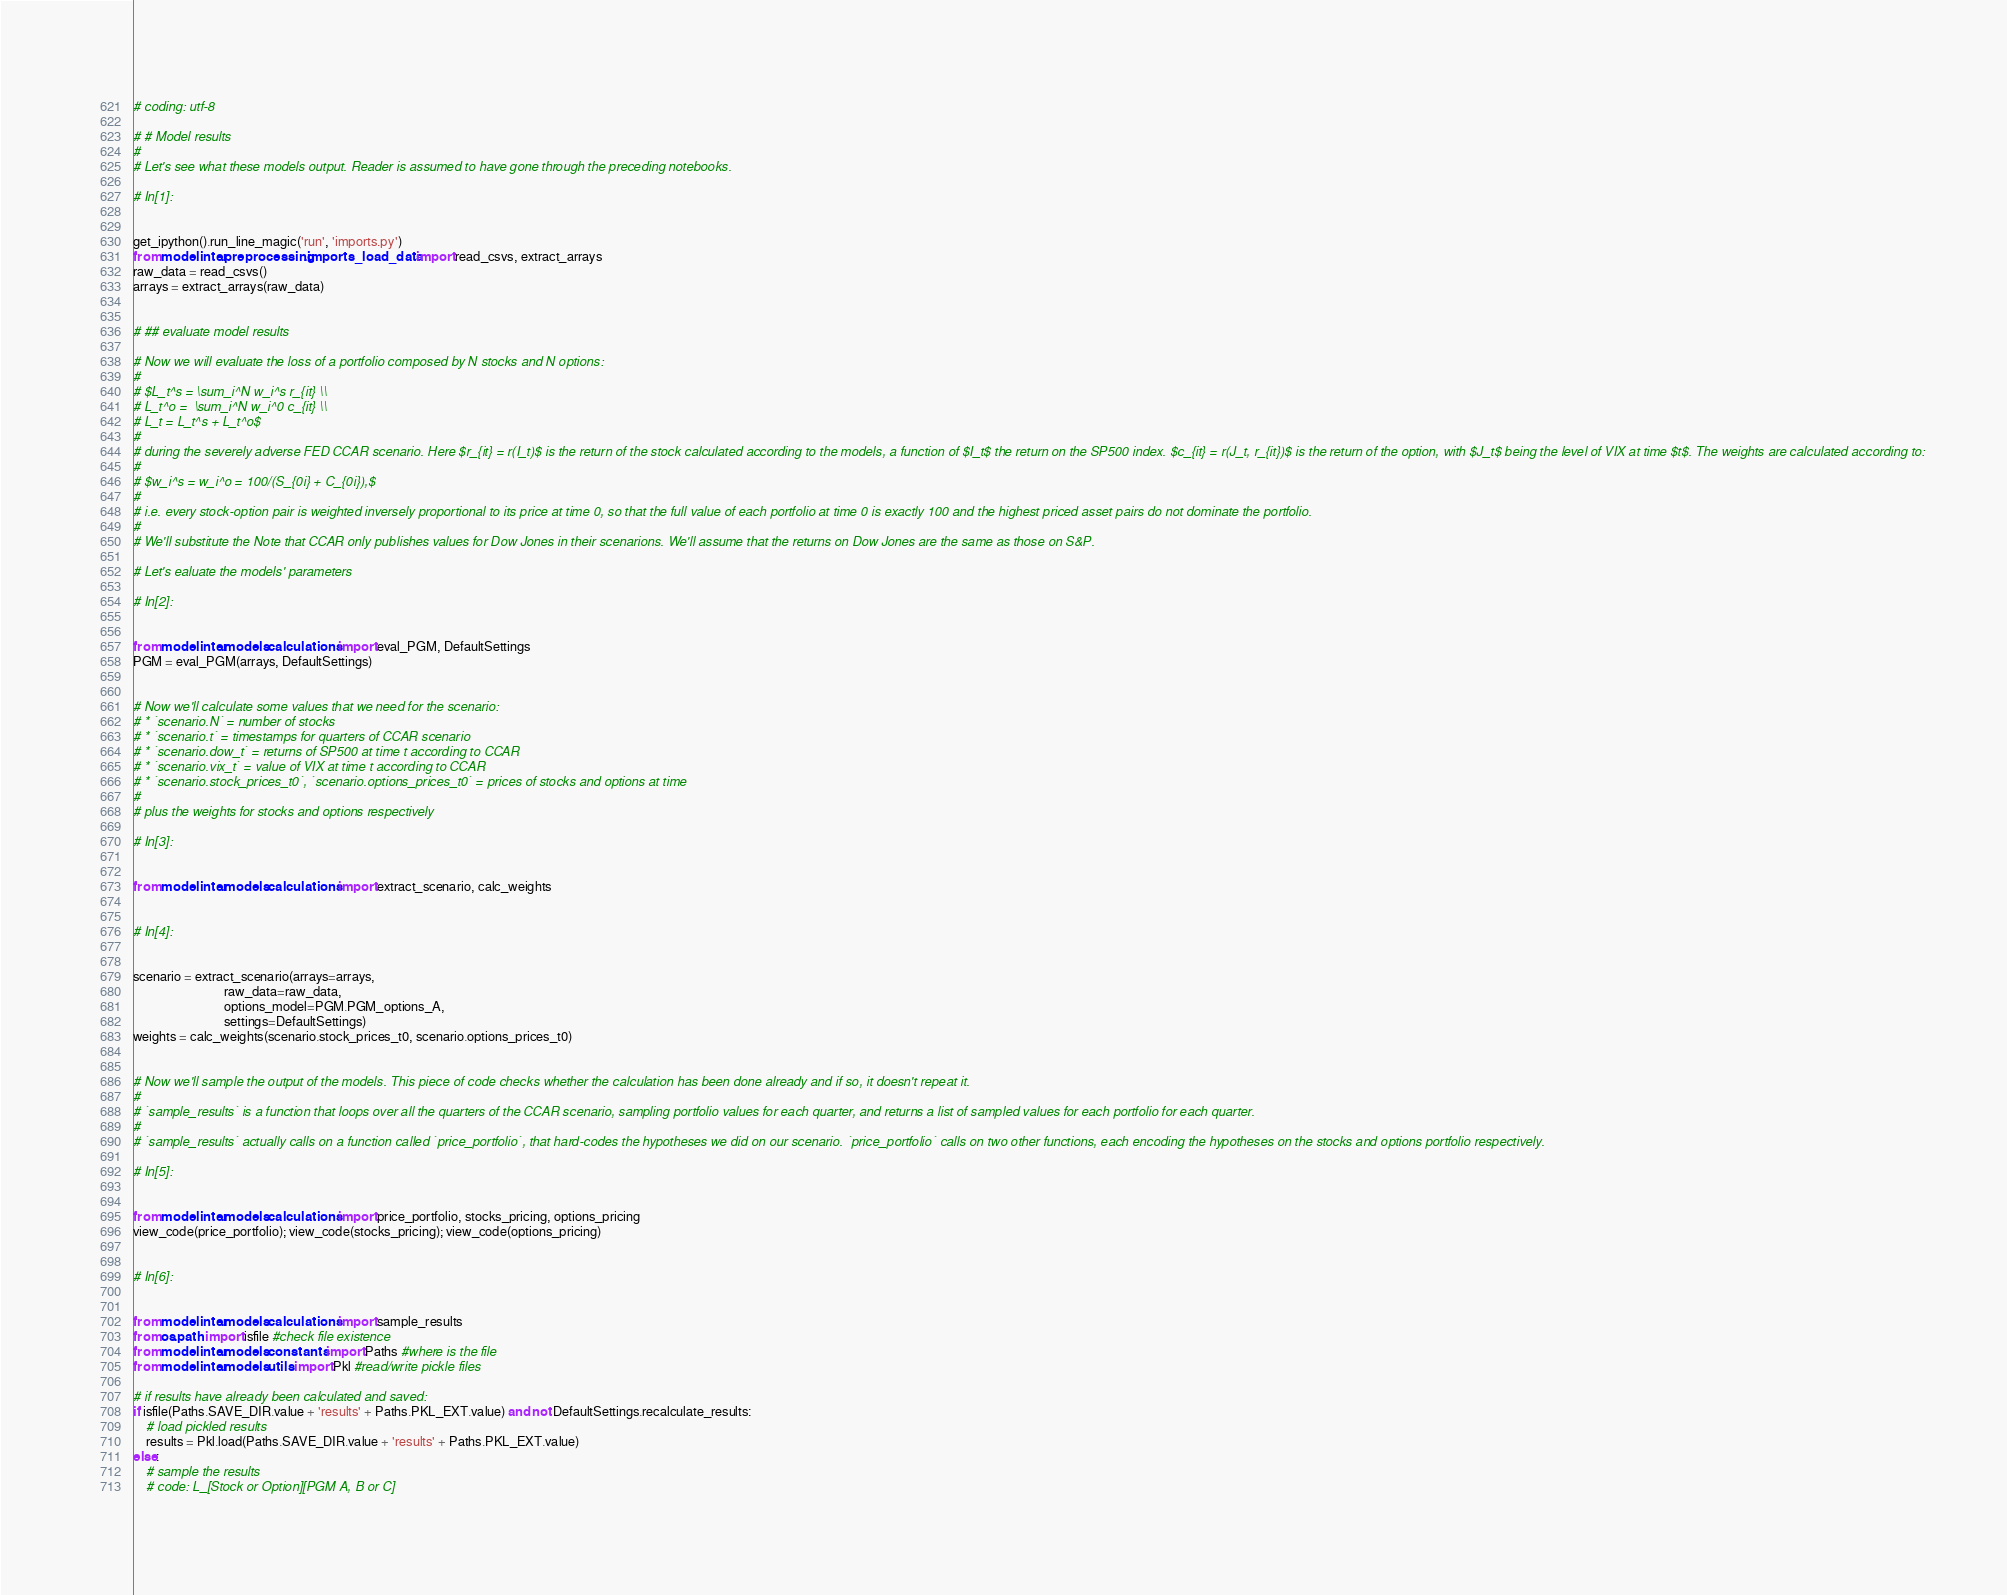<code> <loc_0><loc_0><loc_500><loc_500><_Python_>
# coding: utf-8

# # Model results
# 
# Let's see what these models output. Reader is assumed to have gone through the preceding notebooks.

# In[1]:


get_ipython().run_line_magic('run', 'imports.py')
from modelinter.preprocessing.imports_load_data import read_csvs, extract_arrays
raw_data = read_csvs()
arrays = extract_arrays(raw_data)


# ## evaluate model results

# Now we will evaluate the loss of a portfolio composed by N stocks and N options: 
# 
# $L_t^s = \sum_i^N w_i^s r_{it} \\
# L_t^o =  \sum_i^N w_i^0 c_{it} \\
# L_t = L_t^s + L_t^o$
# 
# during the severely adverse FED CCAR scenario. Here $r_{it} = r(I_t)$ is the return of the stock calculated according to the models, a function of $I_t$ the return on the SP500 index. $c_{it} = r(J_t, r_{it})$ is the return of the option, with $J_t$ being the level of VIX at time $t$. The weights are calculated according to:
# 
# $w_i^s = w_i^o = 100/(S_{0i} + C_{0i}),$
# 
# i.e. every stock-option pair is weighted inversely proportional to its price at time 0, so that the full value of each portfolio at time 0 is exactly 100 and the highest priced asset pairs do not dominate the portfolio.
# 
# We'll substitute the Note that CCAR only publishes values for Dow Jones in their scenarions. We'll assume that the returns on Dow Jones are the same as those on S&P.

# Let's ealuate the models' parameters

# In[2]:


from modelinter.models.calculations import eval_PGM, DefaultSettings
PGM = eval_PGM(arrays, DefaultSettings)


# Now we'll calculate some values that we need for the scenario:
# * `scenario.N` = number of stocks
# * `scenario.t` = timestamps for quarters of CCAR scenario
# * `scenario.dow_t` = returns of SP500 at time t according to CCAR
# * `scenario.vix_t` = value of VIX at time t according to CCAR
# * `scenario.stock_prices_t0`, `scenario.options_prices_t0` = prices of stocks and options at time
# 
# plus the weights for stocks and options respectively

# In[3]:


from modelinter.models.calculations import extract_scenario, calc_weights


# In[4]:


scenario = extract_scenario(arrays=arrays,
                            raw_data=raw_data,
                            options_model=PGM.PGM_options_A,
                            settings=DefaultSettings)
weights = calc_weights(scenario.stock_prices_t0, scenario.options_prices_t0)


# Now we'll sample the output of the models. This piece of code checks whether the calculation has been done already and if so, it doesn't repeat it.
# 
# `sample_results` is a function that loops over all the quarters of the CCAR scenario, sampling portfolio values for each quarter, and returns a list of sampled values for each portfolio for each quarter.
# 
# `sample_results` actually calls on a function called `price_portfolio`, that hard-codes the hypotheses we did on our scenario. `price_portfolio` calls on two other functions, each encoding the hypotheses on the stocks and options portfolio respectively.

# In[5]:


from modelinter.models.calculations import price_portfolio, stocks_pricing, options_pricing
view_code(price_portfolio); view_code(stocks_pricing); view_code(options_pricing)


# In[6]:


from modelinter.models.calculations import sample_results
from os.path import isfile #check file existence
from modelinter.models.constants import Paths #where is the file
from modelinter.models.utils import Pkl #read/write pickle files

# if results have already been calculated and saved:
if isfile(Paths.SAVE_DIR.value + 'results' + Paths.PKL_EXT.value) and not DefaultSettings.recalculate_results:
    # load pickled results
    results = Pkl.load(Paths.SAVE_DIR.value + 'results' + Paths.PKL_EXT.value)
else:
    # sample the results
    # code: L_[Stock or Option][PGM A, B or C]</code> 